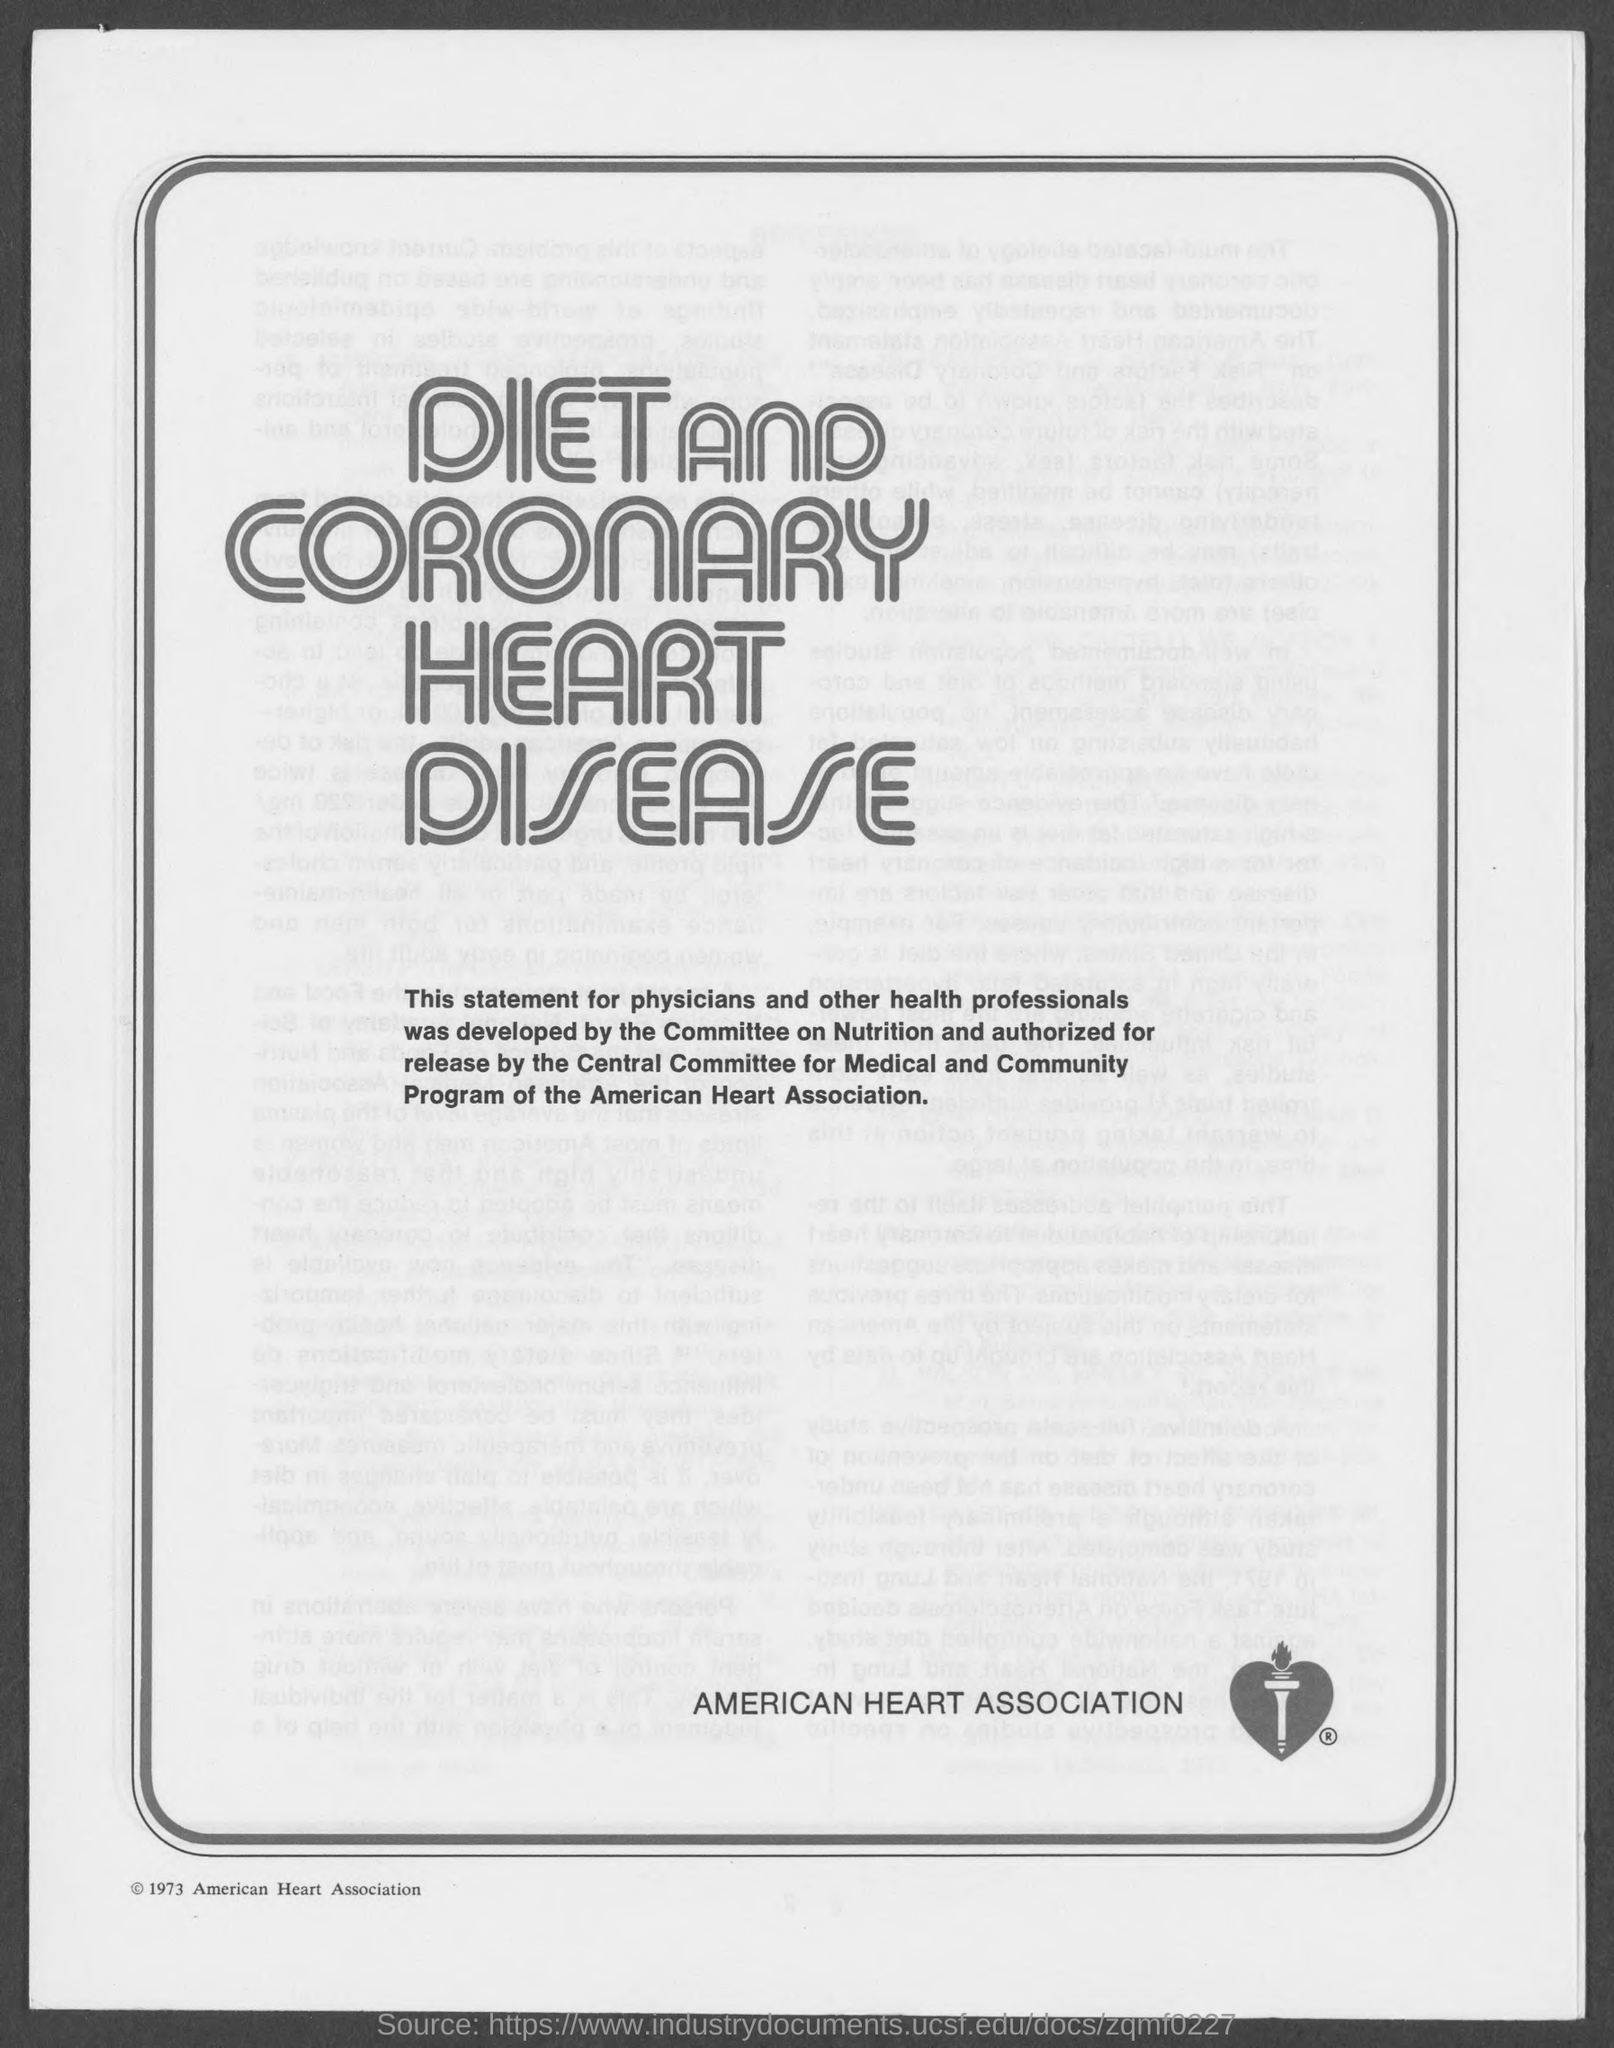What is the name of heart association ?
Offer a terse response. American Heart Association. 